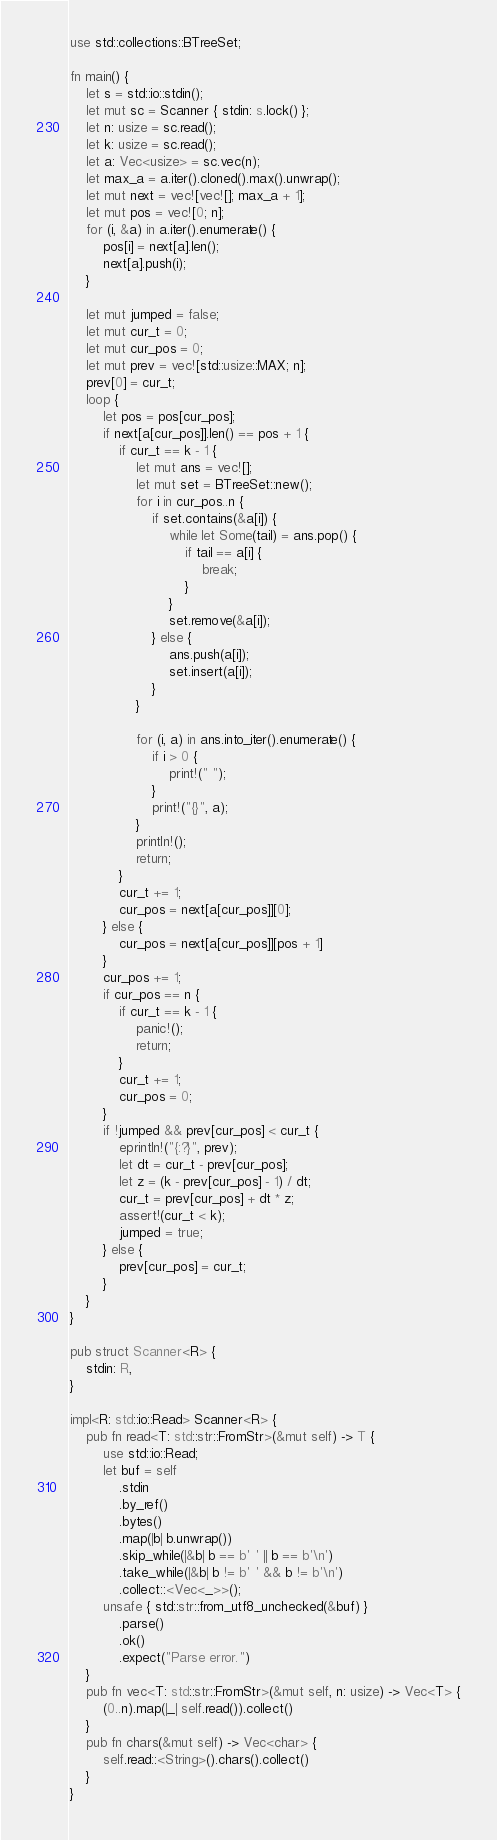<code> <loc_0><loc_0><loc_500><loc_500><_Rust_>use std::collections::BTreeSet;

fn main() {
    let s = std::io::stdin();
    let mut sc = Scanner { stdin: s.lock() };
    let n: usize = sc.read();
    let k: usize = sc.read();
    let a: Vec<usize> = sc.vec(n);
    let max_a = a.iter().cloned().max().unwrap();
    let mut next = vec![vec![]; max_a + 1];
    let mut pos = vec![0; n];
    for (i, &a) in a.iter().enumerate() {
        pos[i] = next[a].len();
        next[a].push(i);
    }

    let mut jumped = false;
    let mut cur_t = 0;
    let mut cur_pos = 0;
    let mut prev = vec![std::usize::MAX; n];
    prev[0] = cur_t;
    loop {
        let pos = pos[cur_pos];
        if next[a[cur_pos]].len() == pos + 1 {
            if cur_t == k - 1 {
                let mut ans = vec![];
                let mut set = BTreeSet::new();
                for i in cur_pos..n {
                    if set.contains(&a[i]) {
                        while let Some(tail) = ans.pop() {
                            if tail == a[i] {
                                break;
                            }
                        }
                        set.remove(&a[i]);
                    } else {
                        ans.push(a[i]);
                        set.insert(a[i]);
                    }
                }

                for (i, a) in ans.into_iter().enumerate() {
                    if i > 0 {
                        print!(" ");
                    }
                    print!("{}", a);
                }
                println!();
                return;
            }
            cur_t += 1;
            cur_pos = next[a[cur_pos]][0];
        } else {
            cur_pos = next[a[cur_pos]][pos + 1]
        }
        cur_pos += 1;
        if cur_pos == n {
            if cur_t == k - 1 {
                panic!();
                return;
            }
            cur_t += 1;
            cur_pos = 0;
        }
        if !jumped && prev[cur_pos] < cur_t {
            eprintln!("{:?}", prev);
            let dt = cur_t - prev[cur_pos];
            let z = (k - prev[cur_pos] - 1) / dt;
            cur_t = prev[cur_pos] + dt * z;
            assert!(cur_t < k);
            jumped = true;
        } else {
            prev[cur_pos] = cur_t;
        }
    }
}

pub struct Scanner<R> {
    stdin: R,
}

impl<R: std::io::Read> Scanner<R> {
    pub fn read<T: std::str::FromStr>(&mut self) -> T {
        use std::io::Read;
        let buf = self
            .stdin
            .by_ref()
            .bytes()
            .map(|b| b.unwrap())
            .skip_while(|&b| b == b' ' || b == b'\n')
            .take_while(|&b| b != b' ' && b != b'\n')
            .collect::<Vec<_>>();
        unsafe { std::str::from_utf8_unchecked(&buf) }
            .parse()
            .ok()
            .expect("Parse error.")
    }
    pub fn vec<T: std::str::FromStr>(&mut self, n: usize) -> Vec<T> {
        (0..n).map(|_| self.read()).collect()
    }
    pub fn chars(&mut self) -> Vec<char> {
        self.read::<String>().chars().collect()
    }
}
</code> 